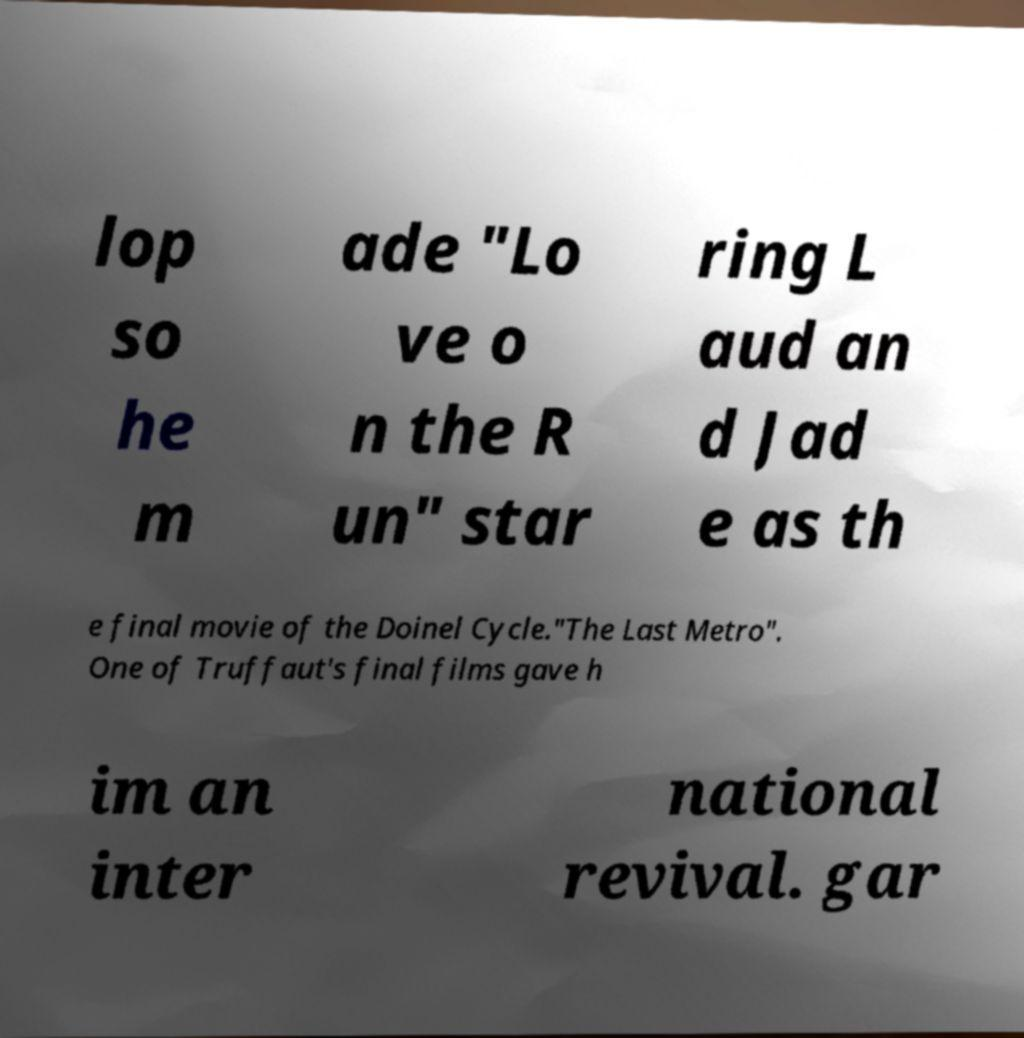Could you extract and type out the text from this image? lop so he m ade "Lo ve o n the R un" star ring L aud an d Jad e as th e final movie of the Doinel Cycle."The Last Metro". One of Truffaut's final films gave h im an inter national revival. gar 